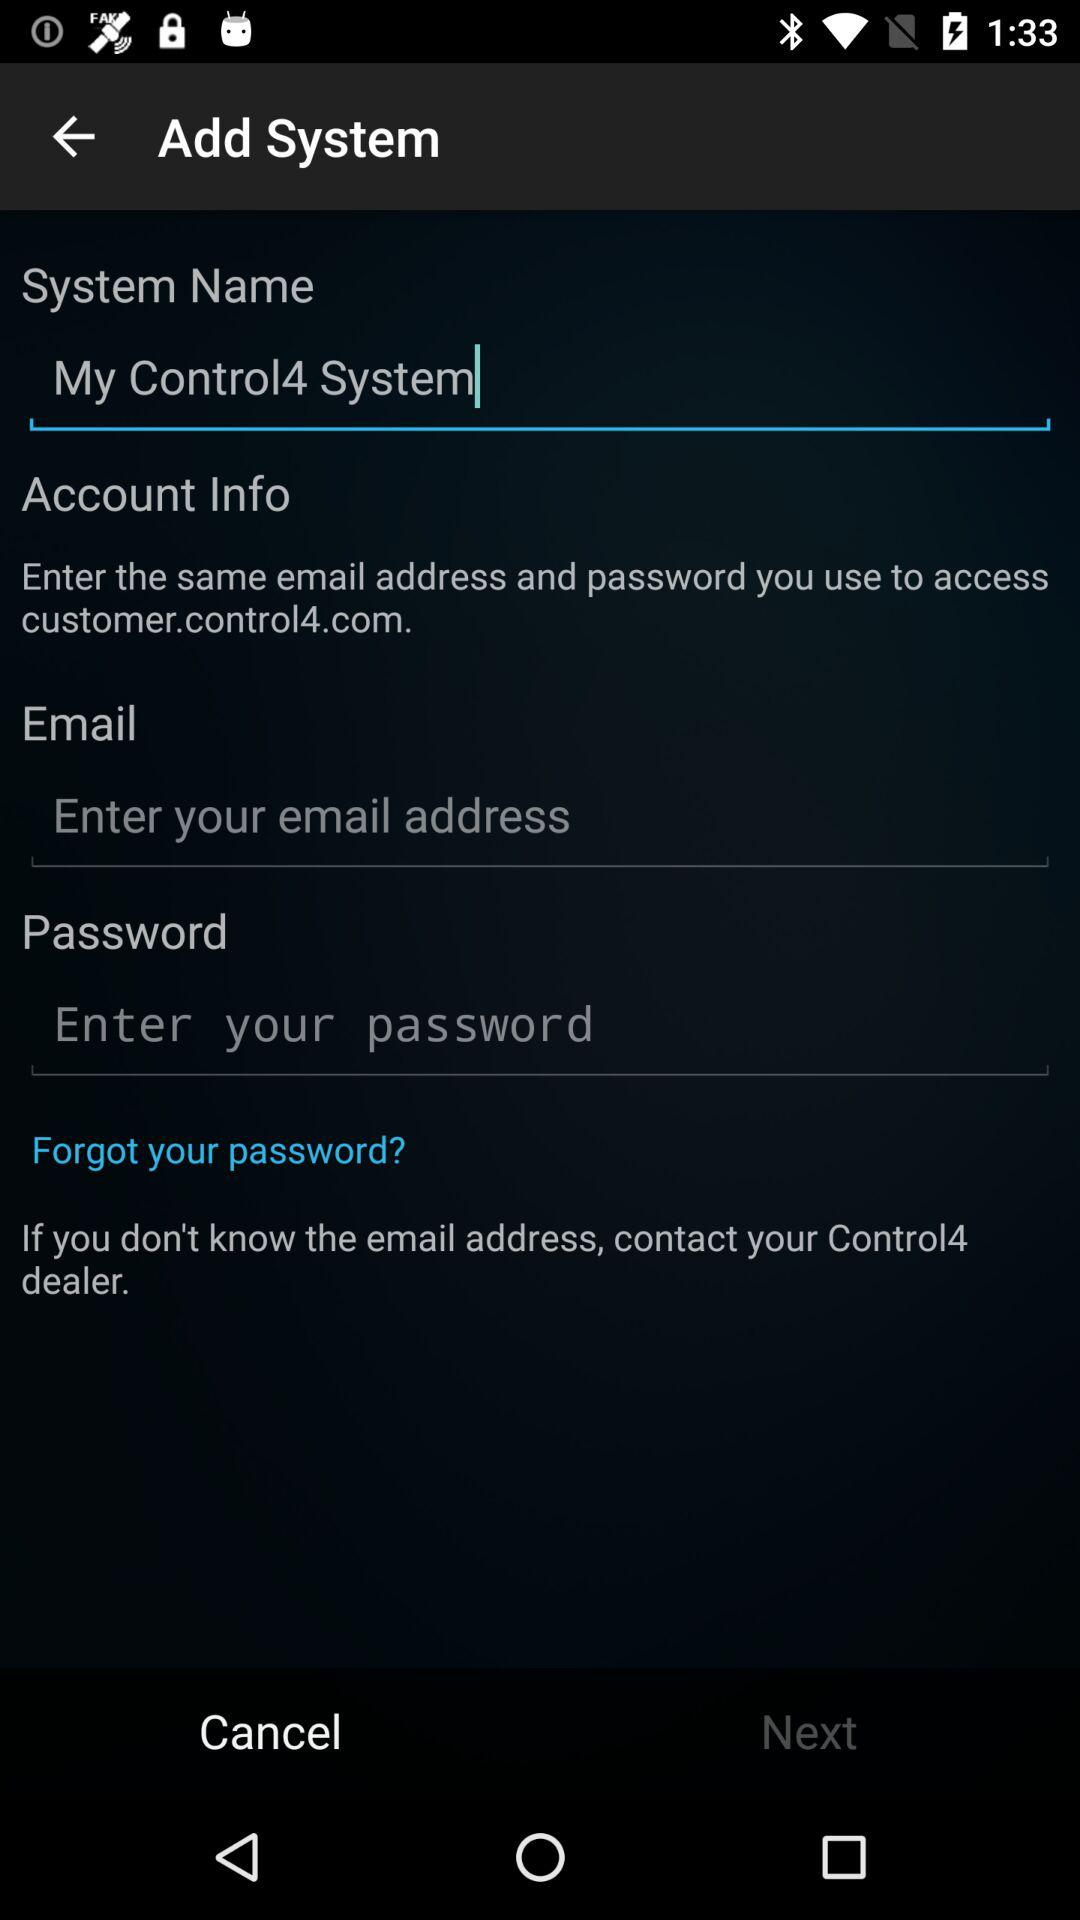How many input fields are there for the account information?
Answer the question using a single word or phrase. 2 